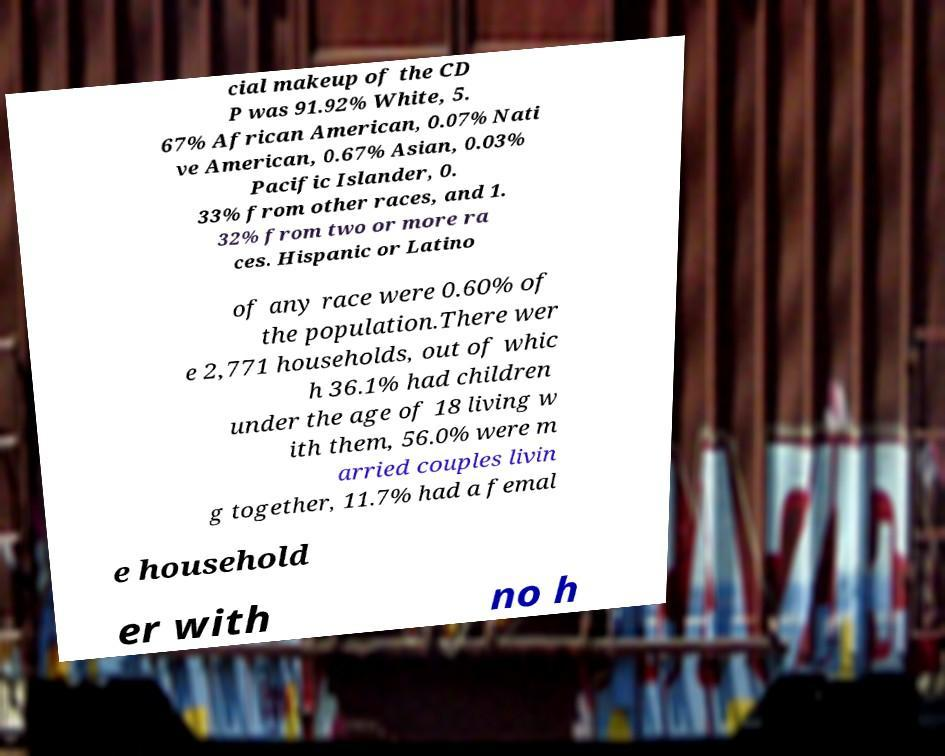What messages or text are displayed in this image? I need them in a readable, typed format. cial makeup of the CD P was 91.92% White, 5. 67% African American, 0.07% Nati ve American, 0.67% Asian, 0.03% Pacific Islander, 0. 33% from other races, and 1. 32% from two or more ra ces. Hispanic or Latino of any race were 0.60% of the population.There wer e 2,771 households, out of whic h 36.1% had children under the age of 18 living w ith them, 56.0% were m arried couples livin g together, 11.7% had a femal e household er with no h 